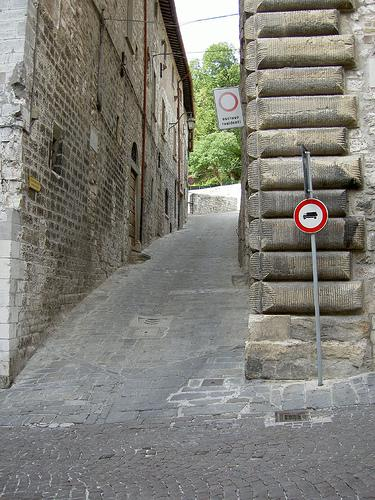Question: what is the picture on the sign in the middle right of the image?
Choices:
A. A deer.
B. A truck.
C. A bus.
D. A pedestrian.
Answer with the letter. Answer: C Question: what color surrounds the bus?
Choices:
A. Black.
B. Brown.
C. White.
D. Blue.
Answer with the letter. Answer: C Question: what color surrounds the white?
Choices:
A. Orange.
B. Yellow.
C. Red.
D. Blue.
Answer with the letter. Answer: C Question: what material are these structures made of?
Choices:
A. Wood.
B. Stone brick.
C. Plastic.
D. Cement.
Answer with the letter. Answer: B Question: what is the only visible organism in this photo?
Choices:
A. Deer.
B. Trees.
C. Grass.
D. People.
Answer with the letter. Answer: B 